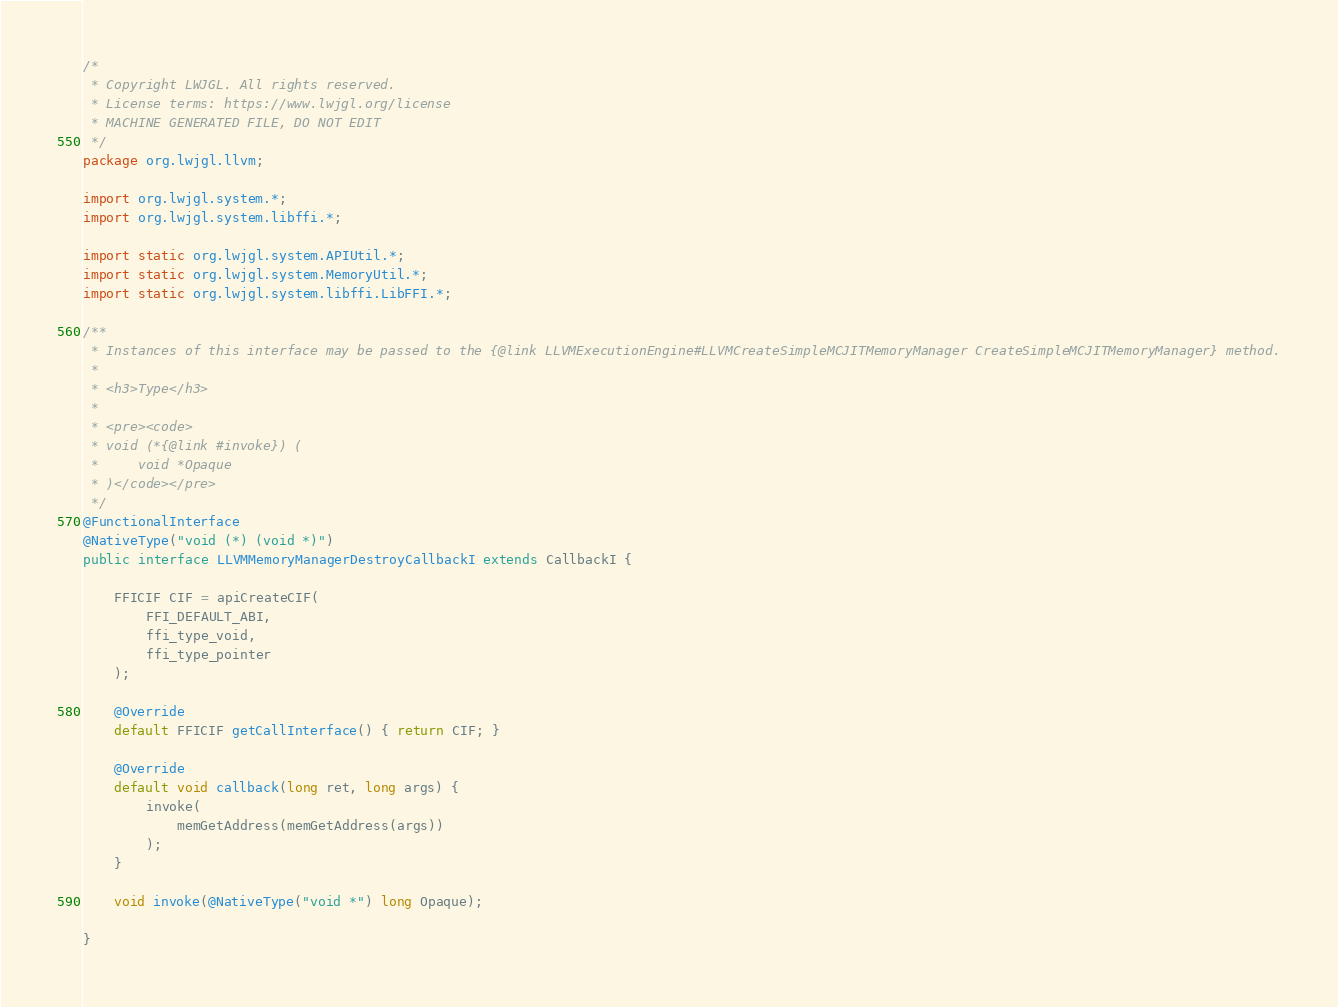Convert code to text. <code><loc_0><loc_0><loc_500><loc_500><_Java_>/*
 * Copyright LWJGL. All rights reserved.
 * License terms: https://www.lwjgl.org/license
 * MACHINE GENERATED FILE, DO NOT EDIT
 */
package org.lwjgl.llvm;

import org.lwjgl.system.*;
import org.lwjgl.system.libffi.*;

import static org.lwjgl.system.APIUtil.*;
import static org.lwjgl.system.MemoryUtil.*;
import static org.lwjgl.system.libffi.LibFFI.*;

/**
 * Instances of this interface may be passed to the {@link LLVMExecutionEngine#LLVMCreateSimpleMCJITMemoryManager CreateSimpleMCJITMemoryManager} method.
 * 
 * <h3>Type</h3>
 * 
 * <pre><code>
 * void (*{@link #invoke}) (
 *     void *Opaque
 * )</code></pre>
 */
@FunctionalInterface
@NativeType("void (*) (void *)")
public interface LLVMMemoryManagerDestroyCallbackI extends CallbackI {

    FFICIF CIF = apiCreateCIF(
        FFI_DEFAULT_ABI,
        ffi_type_void,
        ffi_type_pointer
    );

    @Override
    default FFICIF getCallInterface() { return CIF; }

    @Override
    default void callback(long ret, long args) {
        invoke(
            memGetAddress(memGetAddress(args))
        );
    }

    void invoke(@NativeType("void *") long Opaque);

}</code> 